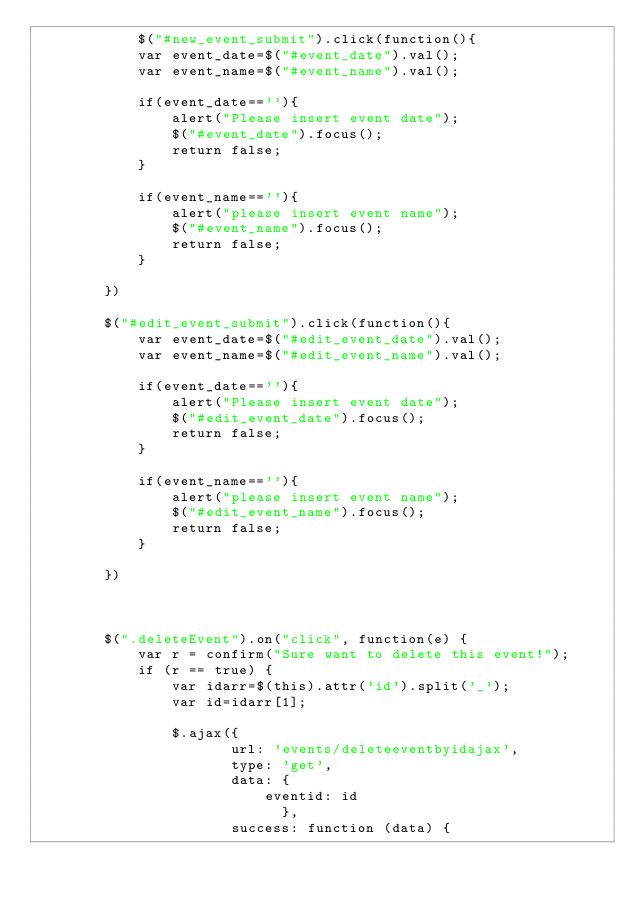Convert code to text. <code><loc_0><loc_0><loc_500><loc_500><_JavaScript_>	    	$("#new_event_submit").click(function(){
            var event_date=$("#event_date").val();
            var event_name=$("#event_name").val();
            
            if(event_date==''){
                alert("Please insert event date");
                $("#event_date").focus();
                return false;
            }
            
            if(event_name==''){
                alert("please insert event name");
                $("#event_name").focus();
                return false;
            }
             
        })
        
        $("#edit_event_submit").click(function(){
            var event_date=$("#edit_event_date").val();
            var event_name=$("#edit_event_name").val();
            
            if(event_date==''){
                alert("Please insert event date");
                $("#edit_event_date").focus();
                return false;
            }
            
            if(event_name==''){
                alert("please insert event name");
                $("#edit_event_name").focus();
                return false;
            }
             
        })
        
        
        
        $(".deleteEvent").on("click", function(e) {
        	var r = confirm("Sure want to delete this event!");
        	if (r == true) {
        		var idarr=$(this).attr('id').split('_');
        		var id=idarr[1];
        		
        		$.ajax({
        		       url: 'events/deleteeventbyidajax',
        		       type: 'get',
        		       data: {
        		    	   eventid: id
        		             },
        		       success: function (data) {</code> 